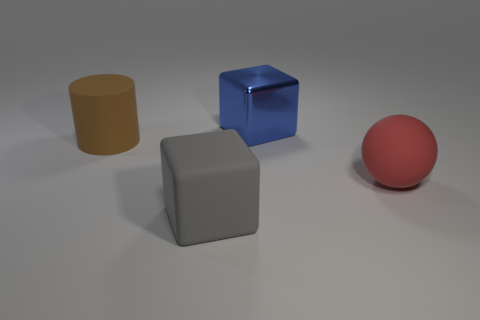Add 4 tiny cyan rubber blocks. How many objects exist? 8 Subtract all spheres. How many objects are left? 3 Add 1 big spheres. How many big spheres exist? 2 Subtract 1 brown cylinders. How many objects are left? 3 Subtract all large red metallic objects. Subtract all gray matte cubes. How many objects are left? 3 Add 2 gray blocks. How many gray blocks are left? 3 